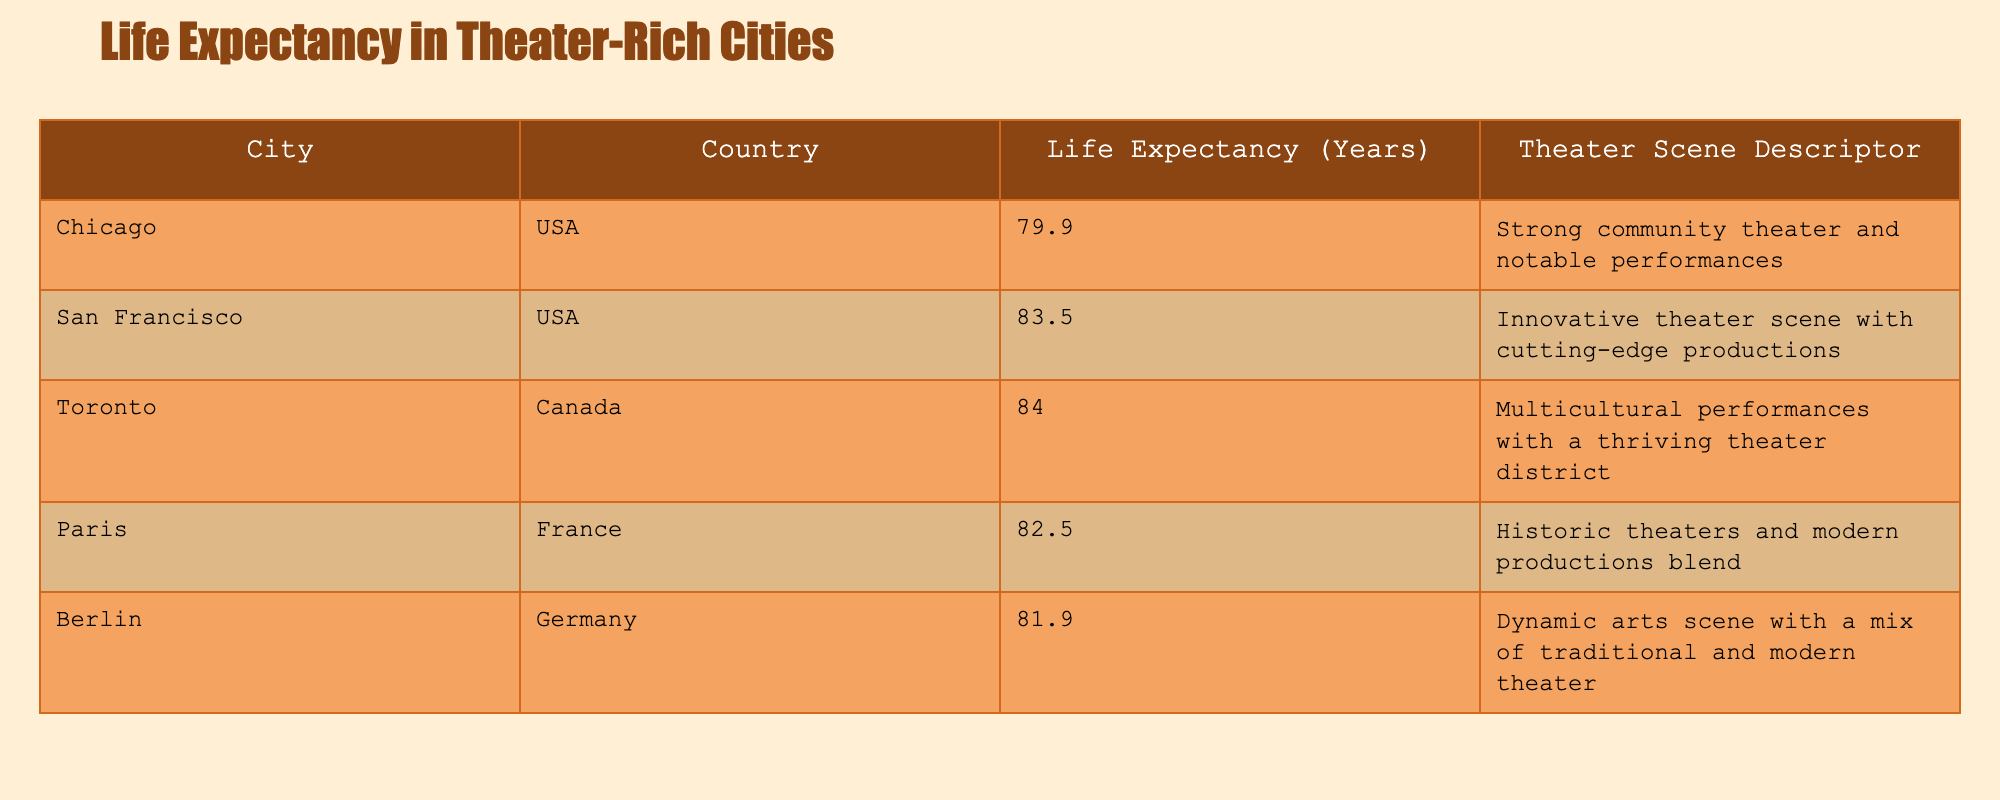What is the life expectancy in San Francisco? The table provides a specific entry for San Francisco under the 'Life Expectancy (Years)' column. The value listed is 83.5.
Answer: 83.5 Which city has the highest life expectancy among those listed? By looking at the 'Life Expectancy (Years)' column, comparing the values reveals that Toronto has the highest life expectancy at 84.0 years.
Answer: Toronto Is the life expectancy in Chicago higher than that in Berlin? The table shows Chicago's life expectancy as 79.9 years, while Berlin's is recorded at 81.9 years. Since 79.9 is less than 81.9, the answer is no.
Answer: No What is the average life expectancy of the cities listed in the table? To find the average, we sum the life expectancy values: 79.9 + 83.5 + 84.0 + 82.5 + 81.9 = 412.8. There are 5 cities, so the average is 412.8 / 5 = 82.56.
Answer: 82.56 Do all cities listed have a life expectancy above 80 years? Checking the life expectancy values, Chicago is at 79.9 years, which is below 80. Therefore, not all cities exceed this threshold.
Answer: No What is the difference in life expectancy between the city with the highest and the city with the lowest? Toronto has the highest life expectancy at 84.0 years, and Chicago has the lowest at 79.9 years. The difference is calculated as 84.0 - 79.9 = 4.1.
Answer: 4.1 Which country has the city with the second highest life expectancy? Toronto in Canada has the second highest life expectancy of 84.0 years. Thus, Canada is the country in question.
Answer: Canada Is Paris's life expectancy closer to Berlin’s or Toronto’s? Paris's life expectancy is 82.5 years, Berlin’s is 81.9 years, and Toronto’s is 84.0 years. The difference to Berlin is 82.5 - 81.9 = 0.6 and the difference to Toronto is 84.0 - 82.5 = 1.5. Since 0.6 is smaller, Paris is closer to Berlin’s life expectancy.
Answer: Berlin 